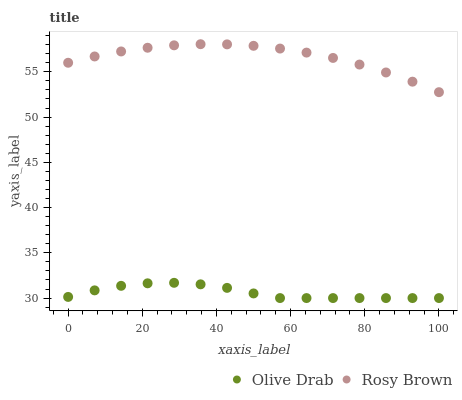Does Olive Drab have the minimum area under the curve?
Answer yes or no. Yes. Does Rosy Brown have the maximum area under the curve?
Answer yes or no. Yes. Does Olive Drab have the maximum area under the curve?
Answer yes or no. No. Is Rosy Brown the smoothest?
Answer yes or no. Yes. Is Olive Drab the roughest?
Answer yes or no. Yes. Is Olive Drab the smoothest?
Answer yes or no. No. Does Olive Drab have the lowest value?
Answer yes or no. Yes. Does Rosy Brown have the highest value?
Answer yes or no. Yes. Does Olive Drab have the highest value?
Answer yes or no. No. Is Olive Drab less than Rosy Brown?
Answer yes or no. Yes. Is Rosy Brown greater than Olive Drab?
Answer yes or no. Yes. Does Olive Drab intersect Rosy Brown?
Answer yes or no. No. 